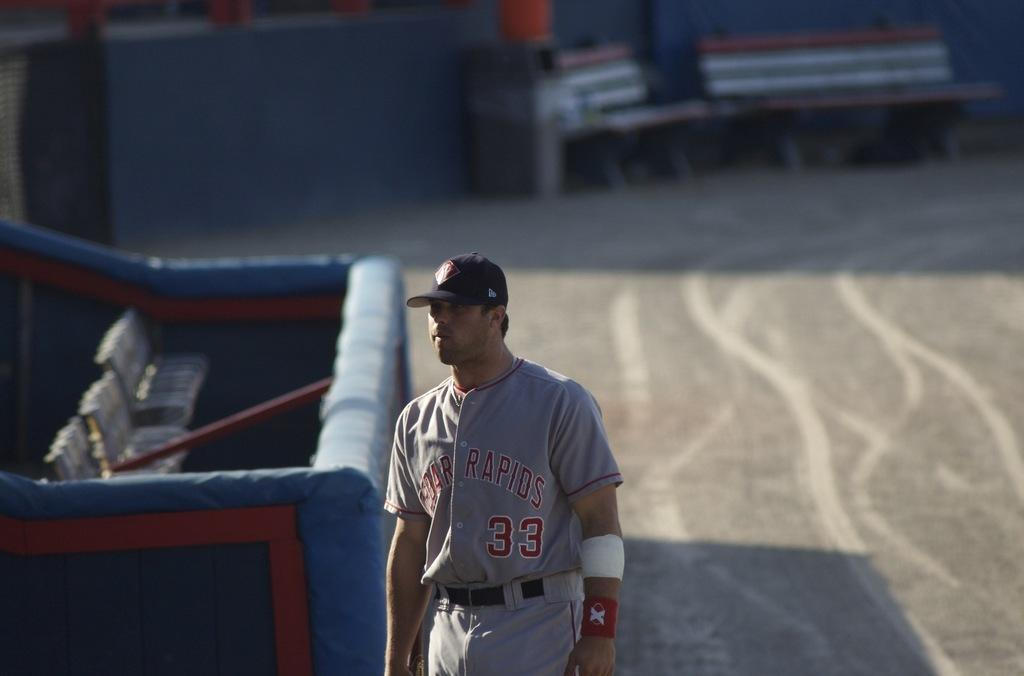Provide a one-sentence caption for the provided image. A baseball player from Cedar Rapids is on the field. 